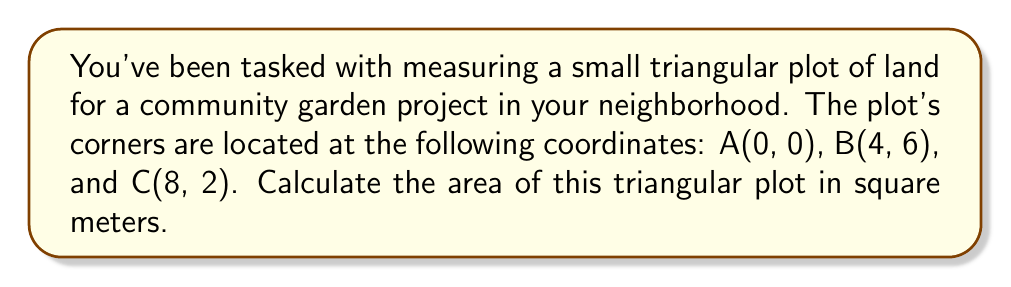Help me with this question. To calculate the area of a triangle using coordinate geometry, we can use the formula:

$$\text{Area} = \frac{1}{2}|x_1(y_2 - y_3) + x_2(y_3 - y_1) + x_3(y_1 - y_2)|$$

Where $(x_1, y_1)$, $(x_2, y_2)$, and $(x_3, y_3)$ are the coordinates of the three vertices of the triangle.

Let's substitute the given coordinates into the formula:
A(0, 0), B(4, 6), and C(8, 2)

$x_1 = 0$, $y_1 = 0$
$x_2 = 4$, $y_2 = 6$
$x_3 = 8$, $y_3 = 2$

Now, let's calculate step by step:

1) $x_1(y_2 - y_3) = 0(6 - 2) = 0(4) = 0$

2) $x_2(y_3 - y_1) = 4(2 - 0) = 4(2) = 8$

3) $x_3(y_1 - y_2) = 8(0 - 6) = 8(-6) = -48$

4) Sum these results: $0 + 8 + (-48) = -40$

5) Take the absolute value: $|-40| = 40$

6) Multiply by $\frac{1}{2}$: $\frac{1}{2} \times 40 = 20$

Therefore, the area of the triangular plot is 20 square meters.

[asy]
unitsize(1cm);
draw((0,0)--(4,6)--(8,2)--cycle);
dot((0,0));
dot((4,6));
dot((8,2));
label("A(0,0)", (0,0), SW);
label("B(4,6)", (4,6), N);
label("C(8,2)", (8,2), SE);
[/asy]
Answer: 20 square meters 